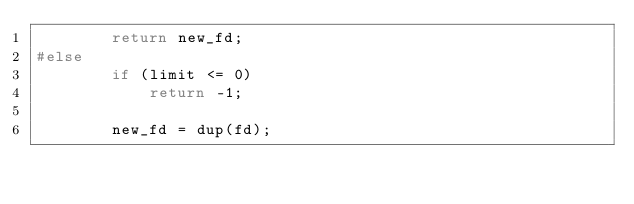Convert code to text. <code><loc_0><loc_0><loc_500><loc_500><_C_>		return new_fd;
#else
		if (limit <= 0)
			return -1;
		
		new_fd = dup(fd);</code> 